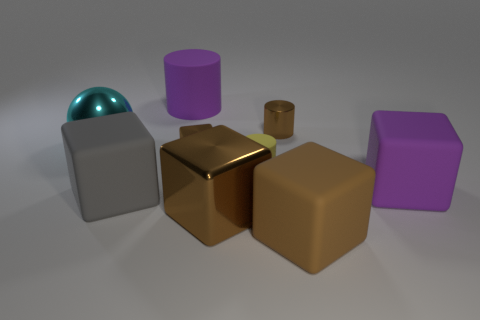Is there a large matte thing that has the same color as the metallic cylinder?
Your answer should be compact. Yes. There is a tiny matte cylinder; are there any objects in front of it?
Offer a very short reply. Yes. There is a tiny object that is the same material as the small block; what color is it?
Ensure brevity in your answer.  Brown. Do the tiny metal block in front of the brown cylinder and the big metal thing right of the large purple cylinder have the same color?
Your answer should be compact. Yes. What number of spheres are either large yellow rubber things or purple rubber objects?
Your answer should be compact. 0. Are there an equal number of big brown metal cubes that are behind the tiny matte thing and small blue cubes?
Make the answer very short. Yes. What is the material of the small brown object behind the small metallic object that is in front of the shiny thing that is to the left of the gray matte cube?
Offer a terse response. Metal. There is a block that is the same color as the big matte cylinder; what material is it?
Offer a very short reply. Rubber. How many objects are either cylinders in front of the small brown metal cylinder or big cyan shiny cubes?
Your answer should be very brief. 1. How many objects are either brown metal things or shiny objects that are in front of the tiny yellow matte thing?
Provide a succinct answer. 3. 